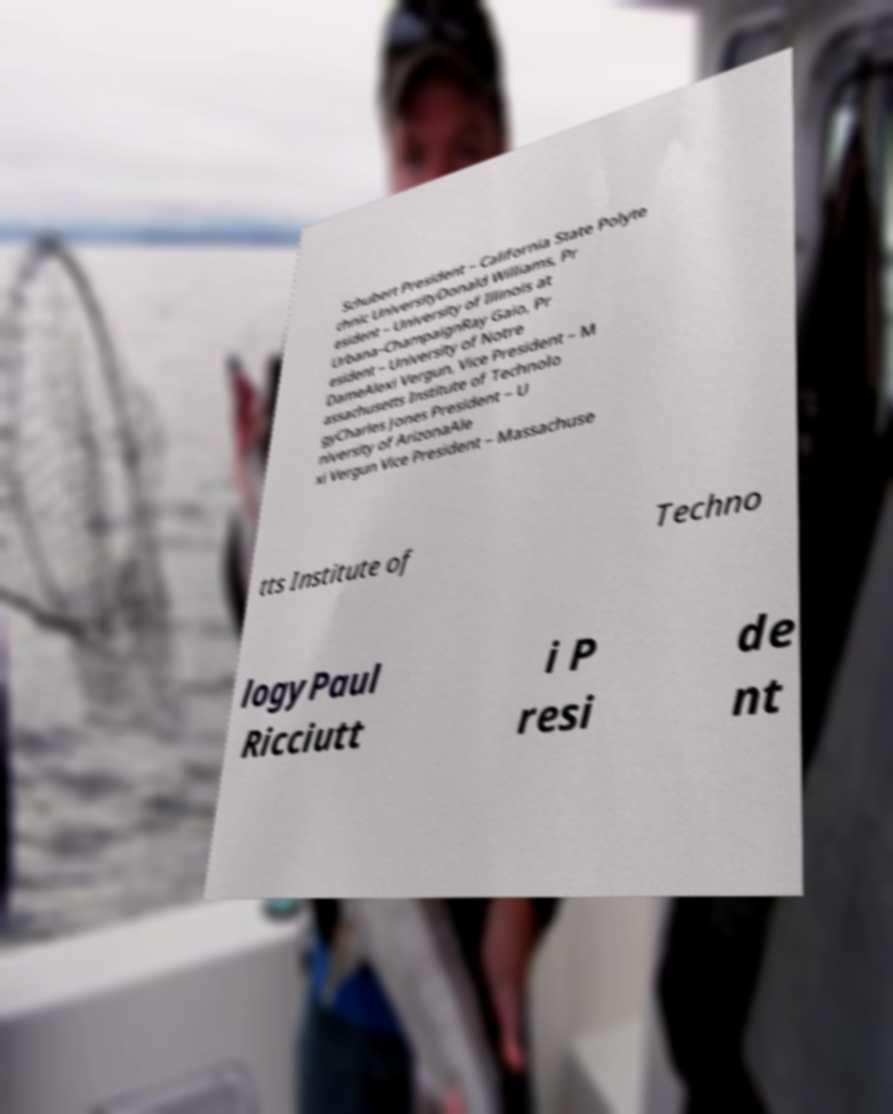Please identify and transcribe the text found in this image. Schubert President – California State Polyte chnic UniversityDonald Williams, Pr esident – University of Illinois at Urbana–ChampaignRay Gaio, Pr esident – University of Notre DameAlexi Vergun, Vice President – M assachusetts Institute of Technolo gyCharles Jones President – U niversity of ArizonaAle xi Vergun Vice President – Massachuse tts Institute of Techno logyPaul Ricciutt i P resi de nt 